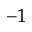<formula> <loc_0><loc_0><loc_500><loc_500>^ { - 1 }</formula> 